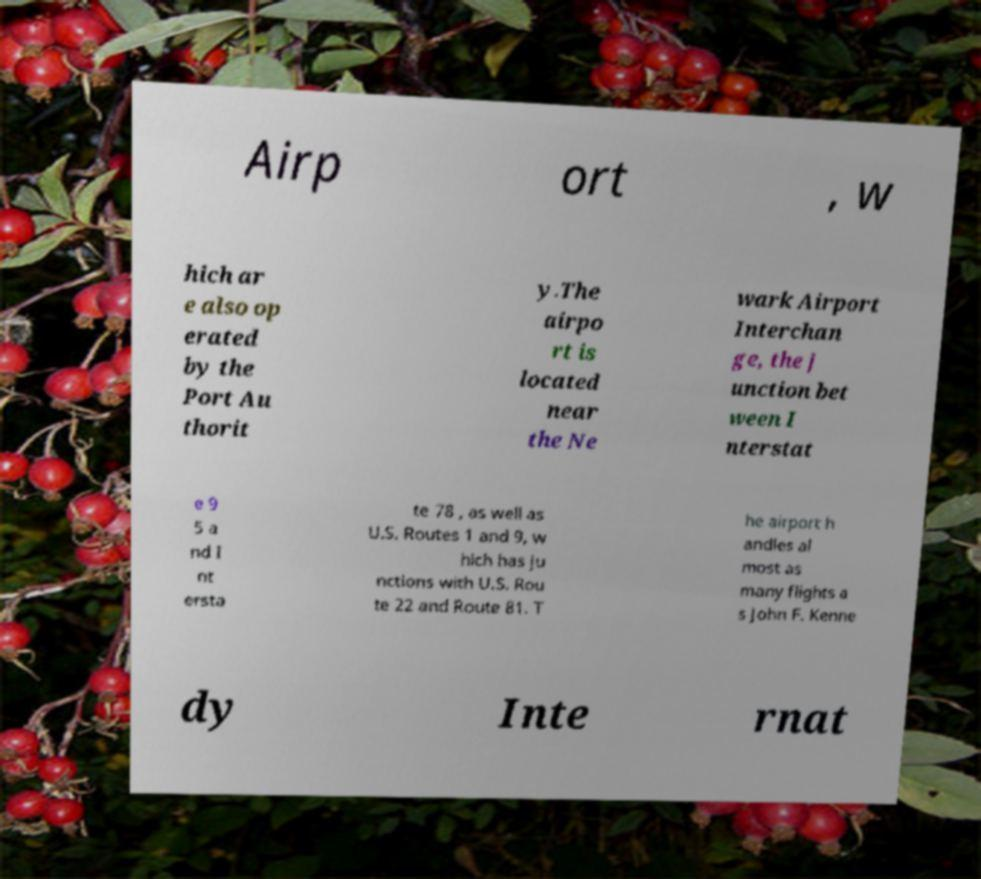For documentation purposes, I need the text within this image transcribed. Could you provide that? Airp ort , w hich ar e also op erated by the Port Au thorit y.The airpo rt is located near the Ne wark Airport Interchan ge, the j unction bet ween I nterstat e 9 5 a nd I nt ersta te 78 , as well as U.S. Routes 1 and 9, w hich has ju nctions with U.S. Rou te 22 and Route 81. T he airport h andles al most as many flights a s John F. Kenne dy Inte rnat 